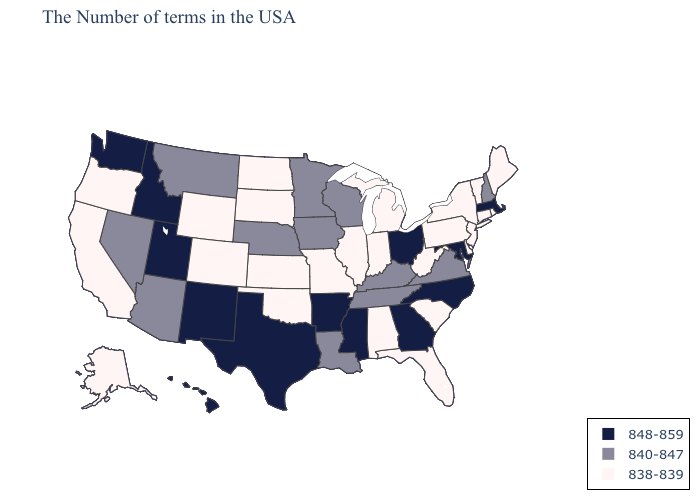Name the states that have a value in the range 838-839?
Keep it brief. Maine, Rhode Island, Vermont, Connecticut, New York, New Jersey, Delaware, Pennsylvania, South Carolina, West Virginia, Florida, Michigan, Indiana, Alabama, Illinois, Missouri, Kansas, Oklahoma, South Dakota, North Dakota, Wyoming, Colorado, California, Oregon, Alaska. Which states have the lowest value in the USA?
Keep it brief. Maine, Rhode Island, Vermont, Connecticut, New York, New Jersey, Delaware, Pennsylvania, South Carolina, West Virginia, Florida, Michigan, Indiana, Alabama, Illinois, Missouri, Kansas, Oklahoma, South Dakota, North Dakota, Wyoming, Colorado, California, Oregon, Alaska. Among the states that border Florida , does Alabama have the highest value?
Concise answer only. No. Does New Hampshire have the highest value in the Northeast?
Keep it brief. No. Name the states that have a value in the range 848-859?
Short answer required. Massachusetts, Maryland, North Carolina, Ohio, Georgia, Mississippi, Arkansas, Texas, New Mexico, Utah, Idaho, Washington, Hawaii. Name the states that have a value in the range 848-859?
Be succinct. Massachusetts, Maryland, North Carolina, Ohio, Georgia, Mississippi, Arkansas, Texas, New Mexico, Utah, Idaho, Washington, Hawaii. Does Connecticut have the same value as South Carolina?
Short answer required. Yes. Name the states that have a value in the range 838-839?
Quick response, please. Maine, Rhode Island, Vermont, Connecticut, New York, New Jersey, Delaware, Pennsylvania, South Carolina, West Virginia, Florida, Michigan, Indiana, Alabama, Illinois, Missouri, Kansas, Oklahoma, South Dakota, North Dakota, Wyoming, Colorado, California, Oregon, Alaska. Among the states that border Pennsylvania , which have the highest value?
Write a very short answer. Maryland, Ohio. How many symbols are there in the legend?
Quick response, please. 3. Does Utah have the highest value in the USA?
Answer briefly. Yes. Does the map have missing data?
Concise answer only. No. What is the value of Georgia?
Concise answer only. 848-859. What is the lowest value in the South?
Give a very brief answer. 838-839. 